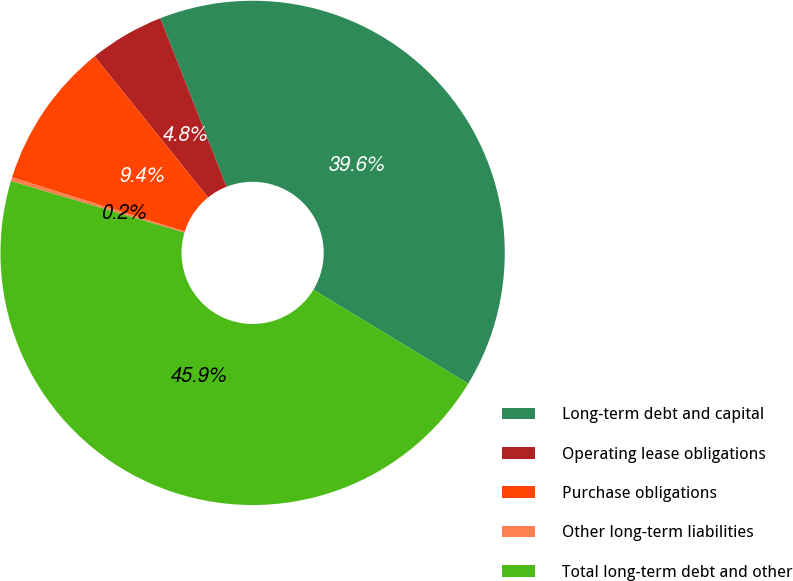<chart> <loc_0><loc_0><loc_500><loc_500><pie_chart><fcel>Long-term debt and capital<fcel>Operating lease obligations<fcel>Purchase obligations<fcel>Other long-term liabilities<fcel>Total long-term debt and other<nl><fcel>39.64%<fcel>4.81%<fcel>9.38%<fcel>0.24%<fcel>45.92%<nl></chart> 